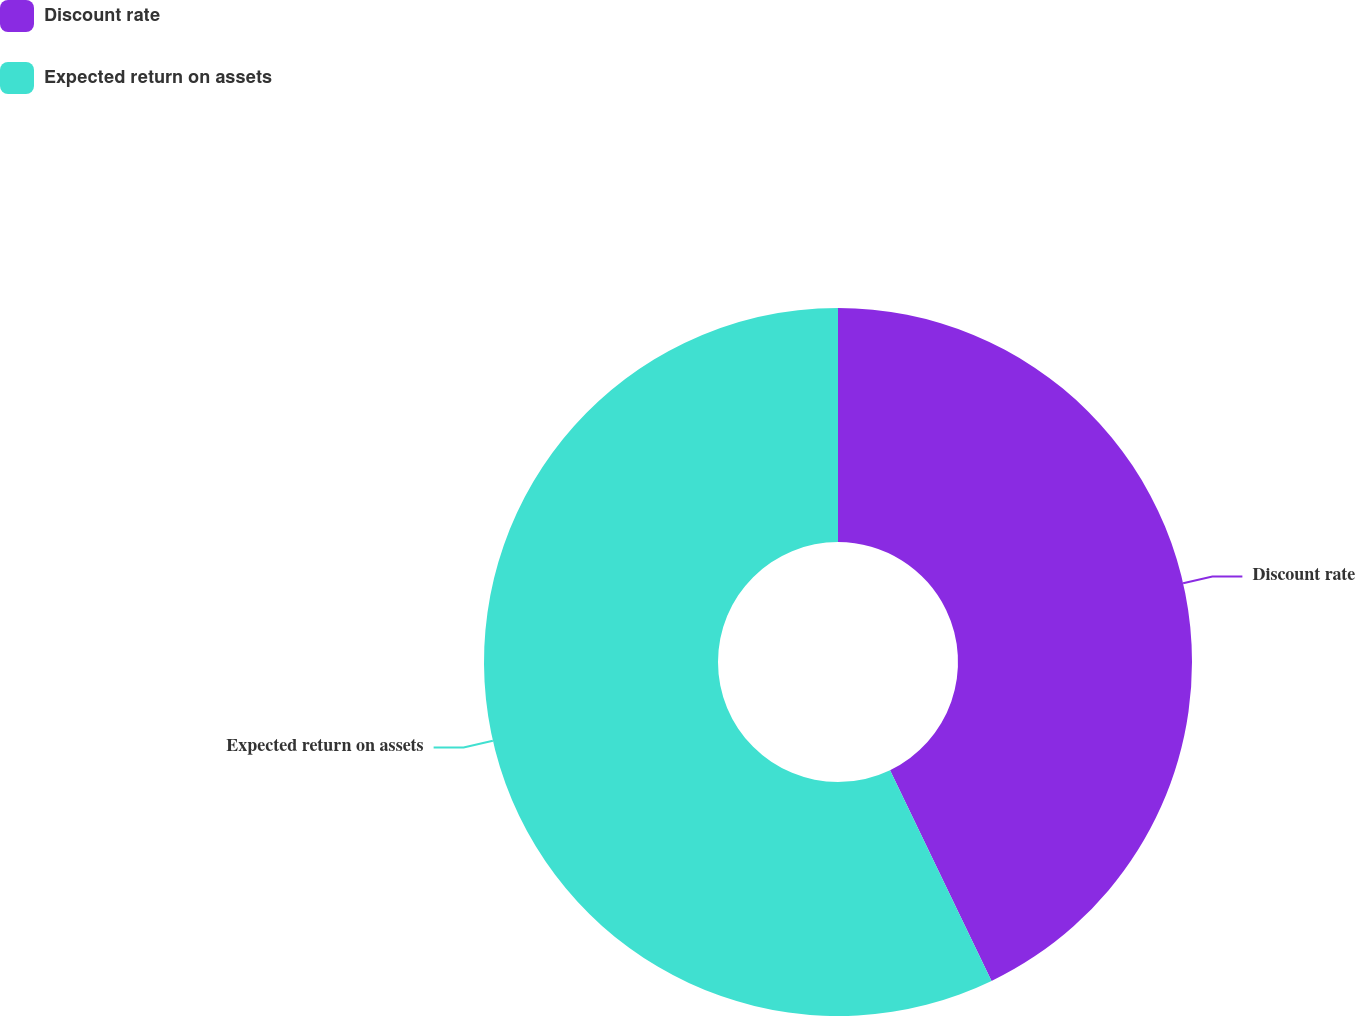<chart> <loc_0><loc_0><loc_500><loc_500><pie_chart><fcel>Discount rate<fcel>Expected return on assets<nl><fcel>42.86%<fcel>57.14%<nl></chart> 